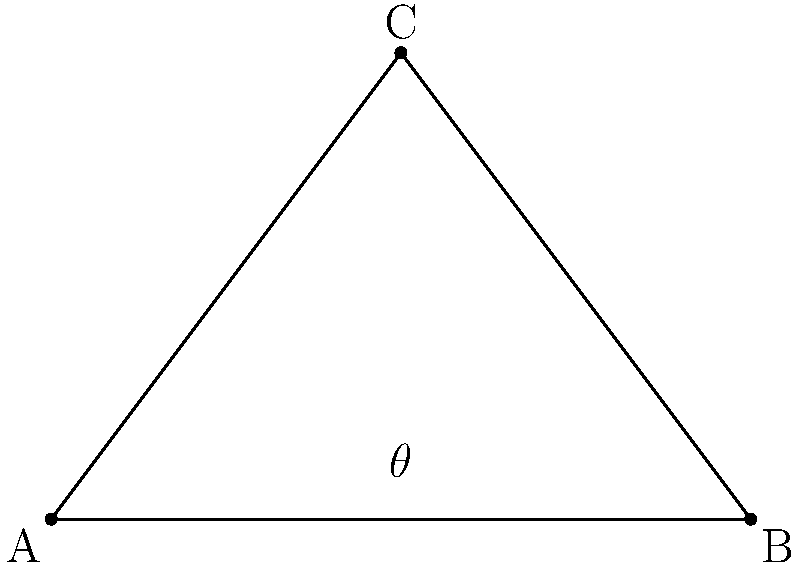A hilltop property is represented by point C(3,4) on a coordinate plane. Two potential viewing points, A(0,0) and B(6,0), are located along the base of the hill. What is the maximum viewing angle $\theta$ (in degrees) from the hilltop to these two points? To find the maximum viewing angle, we need to calculate the angle ACB. We can do this using the following steps:

1) First, calculate the lengths of the sides of the triangle:
   AC = $\sqrt{3^2 + 4^2} = 5$
   BC = $\sqrt{3^2 + 4^2} = 5$
   AB = 6

2) Now we can use the cosine law to find the angle ACB:
   $\cos(\theta) = \frac{AC^2 + BC^2 - AB^2}{2(AC)(BC)}$

3) Substituting the values:
   $\cos(\theta) = \frac{5^2 + 5^2 - 6^2}{2(5)(5)} = \frac{50 - 36}{50} = \frac{14}{50} = 0.28$

4) To get $\theta$, we take the inverse cosine (arccos) of this value:
   $\theta = \arccos(0.28) \approx 73.74$ degrees

Therefore, the maximum viewing angle from the hilltop is approximately 73.74 degrees.
Answer: $73.74°$ 